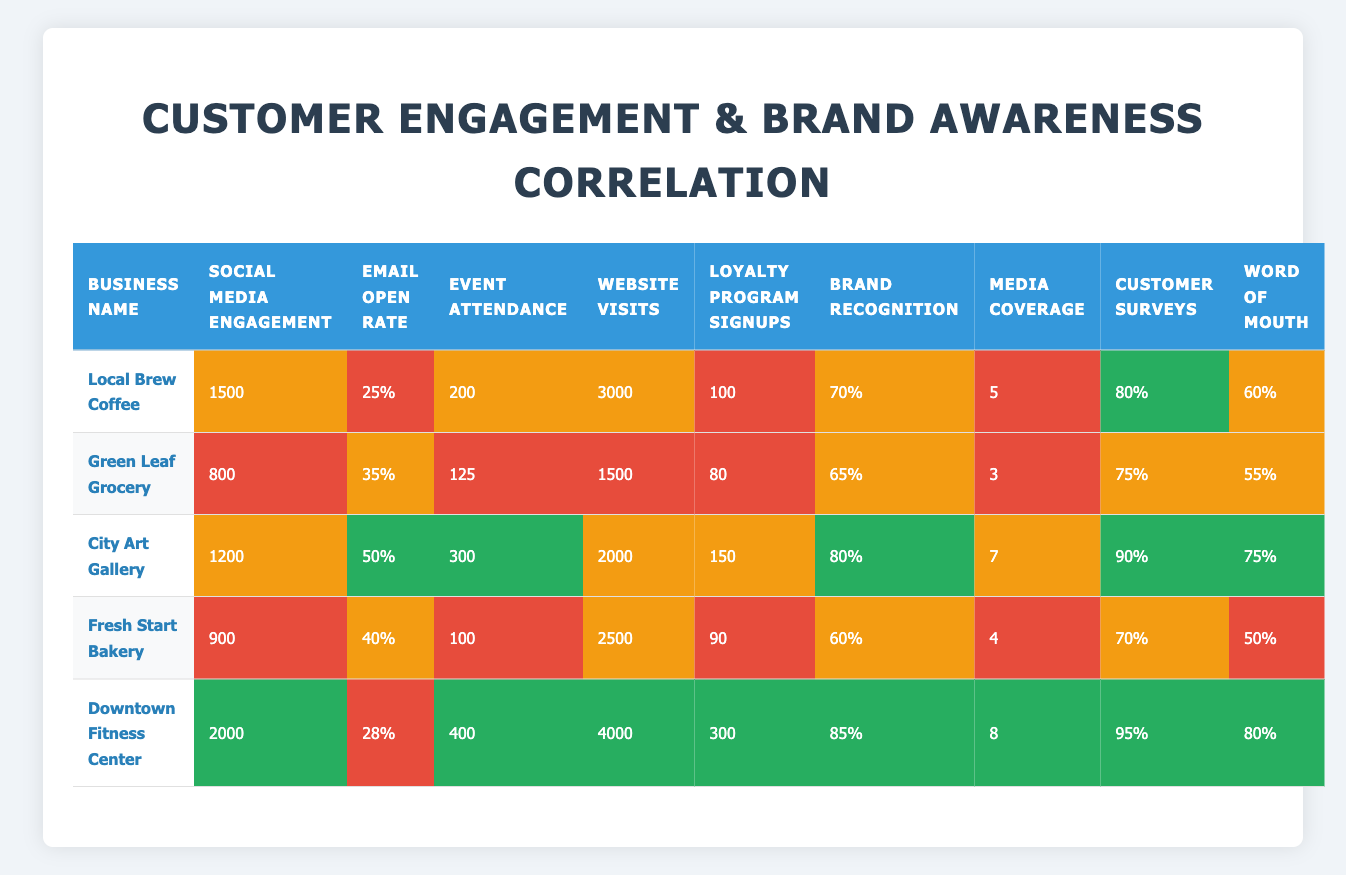What is the social media engagement for Downtown Fitness Center? The table shows that Downtown Fitness Center has a social media engagement of 2000.
Answer: 2000 Which business has the highest brand recognition? The table indicates that Downtown Fitness Center has the highest brand recognition at 85%.
Answer: 85% What is the average email open rate for all businesses? To find the average email open rate, sum the open rates (25 + 35 + 50 + 40 + 28) = 178. There are 5 businesses, so the average is 178/5 = 35.6.
Answer: 35.6 Is the website visits for Fresh Start Bakery greater than those for Green Leaf Grocery? Fresh Start Bakery has 2500 website visits, while Green Leaf Grocery has 1500 website visits. Since 2500 is greater than 1500, the statement is true.
Answer: Yes How many businesses have a word of mouth score higher than 70? From the table, City Art Gallery (75) and Downtown Fitness Center (80) are the two businesses with a word of mouth score higher than 70. Therefore, there are 2 such businesses.
Answer: 2 What is the total event attendance across all businesses? To find the total event attendance, add the attendance numbers (200 + 125 + 300 + 100 + 400) = 1125.
Answer: 1125 Does Green Leaf Grocery have the lowest media coverage among the businesses? The media coverage for Green Leaf Grocery is 3, which is lower than the media coverages for the other businesses (5, 7, 4, and 8). Therefore, it is accurate to say that Green Leaf Grocery has the lowest media coverage.
Answer: Yes What is the difference in loyalty program signups between City Art Gallery and Downtown Fitness Center? City Art Gallery has 150 loyalty program signups and Downtown Fitness Center has 300 signups. The difference is 300 - 150 = 150.
Answer: 150 Which business has the highest number of website visits, and what is the value? Analyzing the website visits, Downtown Fitness Center has the highest number at 4000.
Answer: Downtown Fitness Center, 4000 